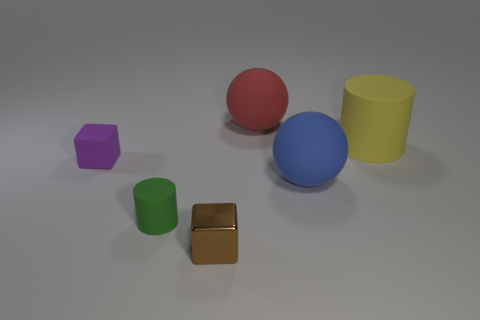Add 4 big red rubber things. How many objects exist? 10 Subtract 2 cylinders. How many cylinders are left? 0 Subtract 0 green spheres. How many objects are left? 6 Subtract all blocks. How many objects are left? 4 Subtract all yellow cylinders. Subtract all blue balls. How many cylinders are left? 1 Subtract all blue cylinders. How many purple cubes are left? 1 Subtract all large matte cylinders. Subtract all matte spheres. How many objects are left? 3 Add 5 blue balls. How many blue balls are left? 6 Add 3 small gray blocks. How many small gray blocks exist? 3 